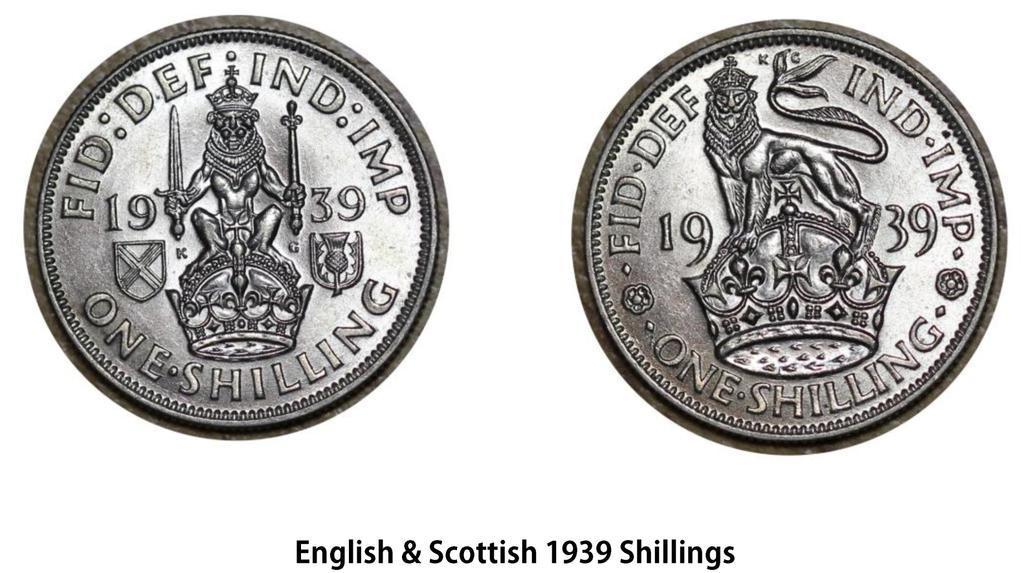<image>
Render a clear and concise summary of the photo. Two coins that says 1939 and worth one shilling 